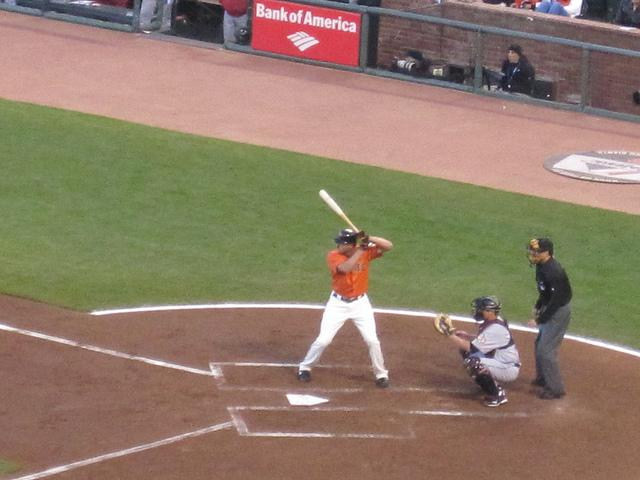What type of service sponsors this stadium? Please explain your reasoning. banking. The sign in the bankground, says bank of america, indicating that company has paid for advertising in this stadium. 